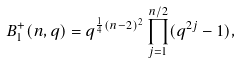Convert formula to latex. <formula><loc_0><loc_0><loc_500><loc_500>B _ { 1 } ^ { + } ( n , q ) = q ^ { \frac { 1 } { 4 } ( n - 2 ) ^ { 2 } } \prod _ { j = 1 } ^ { n / 2 } ( q ^ { 2 j } - 1 ) ,</formula> 